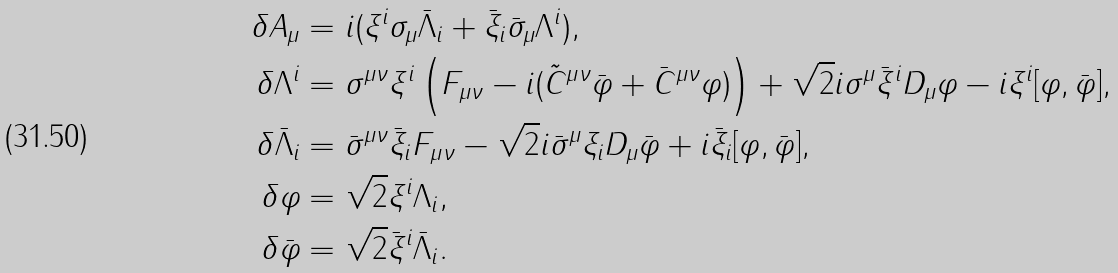Convert formula to latex. <formula><loc_0><loc_0><loc_500><loc_500>\delta A _ { \mu } & = i ( \xi ^ { i } \sigma _ { \mu } \bar { \Lambda } _ { i } + \bar { \xi } _ { i } \bar { \sigma } _ { \mu } \Lambda ^ { i } ) , \\ \delta \Lambda ^ { i } & = \sigma ^ { \mu \nu } \xi ^ { i } \left ( F _ { \mu \nu } - i ( \tilde { C } ^ { \mu \nu } \bar { \varphi } + \bar { C } ^ { \mu \nu } \varphi ) \right ) + \sqrt { 2 } i \sigma ^ { \mu } \bar { \xi } ^ { i } D _ { \mu } \varphi - i \xi ^ { i } [ \varphi , \bar { \varphi } ] , \\ \delta \bar { \Lambda } _ { i } & = \bar { \sigma } ^ { \mu \nu } \bar { \xi } _ { i } F _ { \mu \nu } - \sqrt { 2 } i \bar { \sigma } ^ { \mu } \xi _ { i } D _ { \mu } \bar { \varphi } + i \bar { \xi } _ { i } [ \varphi , \bar { \varphi } ] , \\ \delta \varphi & = \sqrt { 2 } \xi ^ { i } \Lambda _ { i } , \\ \delta \bar { \varphi } & = \sqrt { 2 } \bar { \xi } ^ { i } \bar { \Lambda } _ { i } .</formula> 